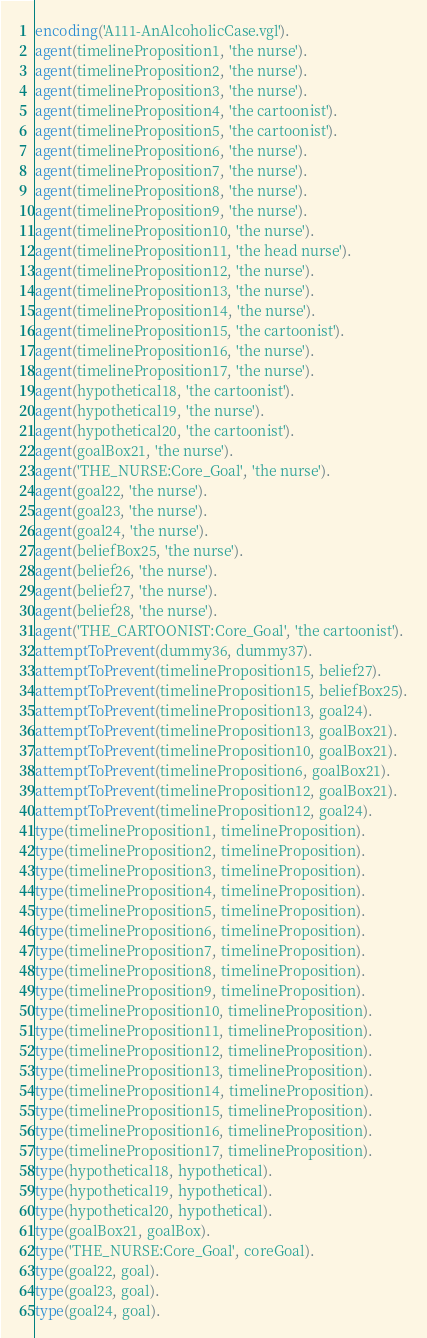Convert code to text. <code><loc_0><loc_0><loc_500><loc_500><_Prolog_>encoding('A111-AnAlcoholicCase.vgl').
agent(timelineProposition1, 'the nurse').
agent(timelineProposition2, 'the nurse').
agent(timelineProposition3, 'the nurse').
agent(timelineProposition4, 'the cartoonist').
agent(timelineProposition5, 'the cartoonist').
agent(timelineProposition6, 'the nurse').
agent(timelineProposition7, 'the nurse').
agent(timelineProposition8, 'the nurse').
agent(timelineProposition9, 'the nurse').
agent(timelineProposition10, 'the nurse').
agent(timelineProposition11, 'the head nurse').
agent(timelineProposition12, 'the nurse').
agent(timelineProposition13, 'the nurse').
agent(timelineProposition14, 'the nurse').
agent(timelineProposition15, 'the cartoonist').
agent(timelineProposition16, 'the nurse').
agent(timelineProposition17, 'the nurse').
agent(hypothetical18, 'the cartoonist').
agent(hypothetical19, 'the nurse').
agent(hypothetical20, 'the cartoonist').
agent(goalBox21, 'the nurse').
agent('THE_NURSE:Core_Goal', 'the nurse').
agent(goal22, 'the nurse').
agent(goal23, 'the nurse').
agent(goal24, 'the nurse').
agent(beliefBox25, 'the nurse').
agent(belief26, 'the nurse').
agent(belief27, 'the nurse').
agent(belief28, 'the nurse').
agent('THE_CARTOONIST:Core_Goal', 'the cartoonist').
attemptToPrevent(dummy36, dummy37).
attemptToPrevent(timelineProposition15, belief27).
attemptToPrevent(timelineProposition15, beliefBox25).
attemptToPrevent(timelineProposition13, goal24).
attemptToPrevent(timelineProposition13, goalBox21).
attemptToPrevent(timelineProposition10, goalBox21).
attemptToPrevent(timelineProposition6, goalBox21).
attemptToPrevent(timelineProposition12, goalBox21).
attemptToPrevent(timelineProposition12, goal24).
type(timelineProposition1, timelineProposition).
type(timelineProposition2, timelineProposition).
type(timelineProposition3, timelineProposition).
type(timelineProposition4, timelineProposition).
type(timelineProposition5, timelineProposition).
type(timelineProposition6, timelineProposition).
type(timelineProposition7, timelineProposition).
type(timelineProposition8, timelineProposition).
type(timelineProposition9, timelineProposition).
type(timelineProposition10, timelineProposition).
type(timelineProposition11, timelineProposition).
type(timelineProposition12, timelineProposition).
type(timelineProposition13, timelineProposition).
type(timelineProposition14, timelineProposition).
type(timelineProposition15, timelineProposition).
type(timelineProposition16, timelineProposition).
type(timelineProposition17, timelineProposition).
type(hypothetical18, hypothetical).
type(hypothetical19, hypothetical).
type(hypothetical20, hypothetical).
type(goalBox21, goalBox).
type('THE_NURSE:Core_Goal', coreGoal).
type(goal22, goal).
type(goal23, goal).
type(goal24, goal).</code> 